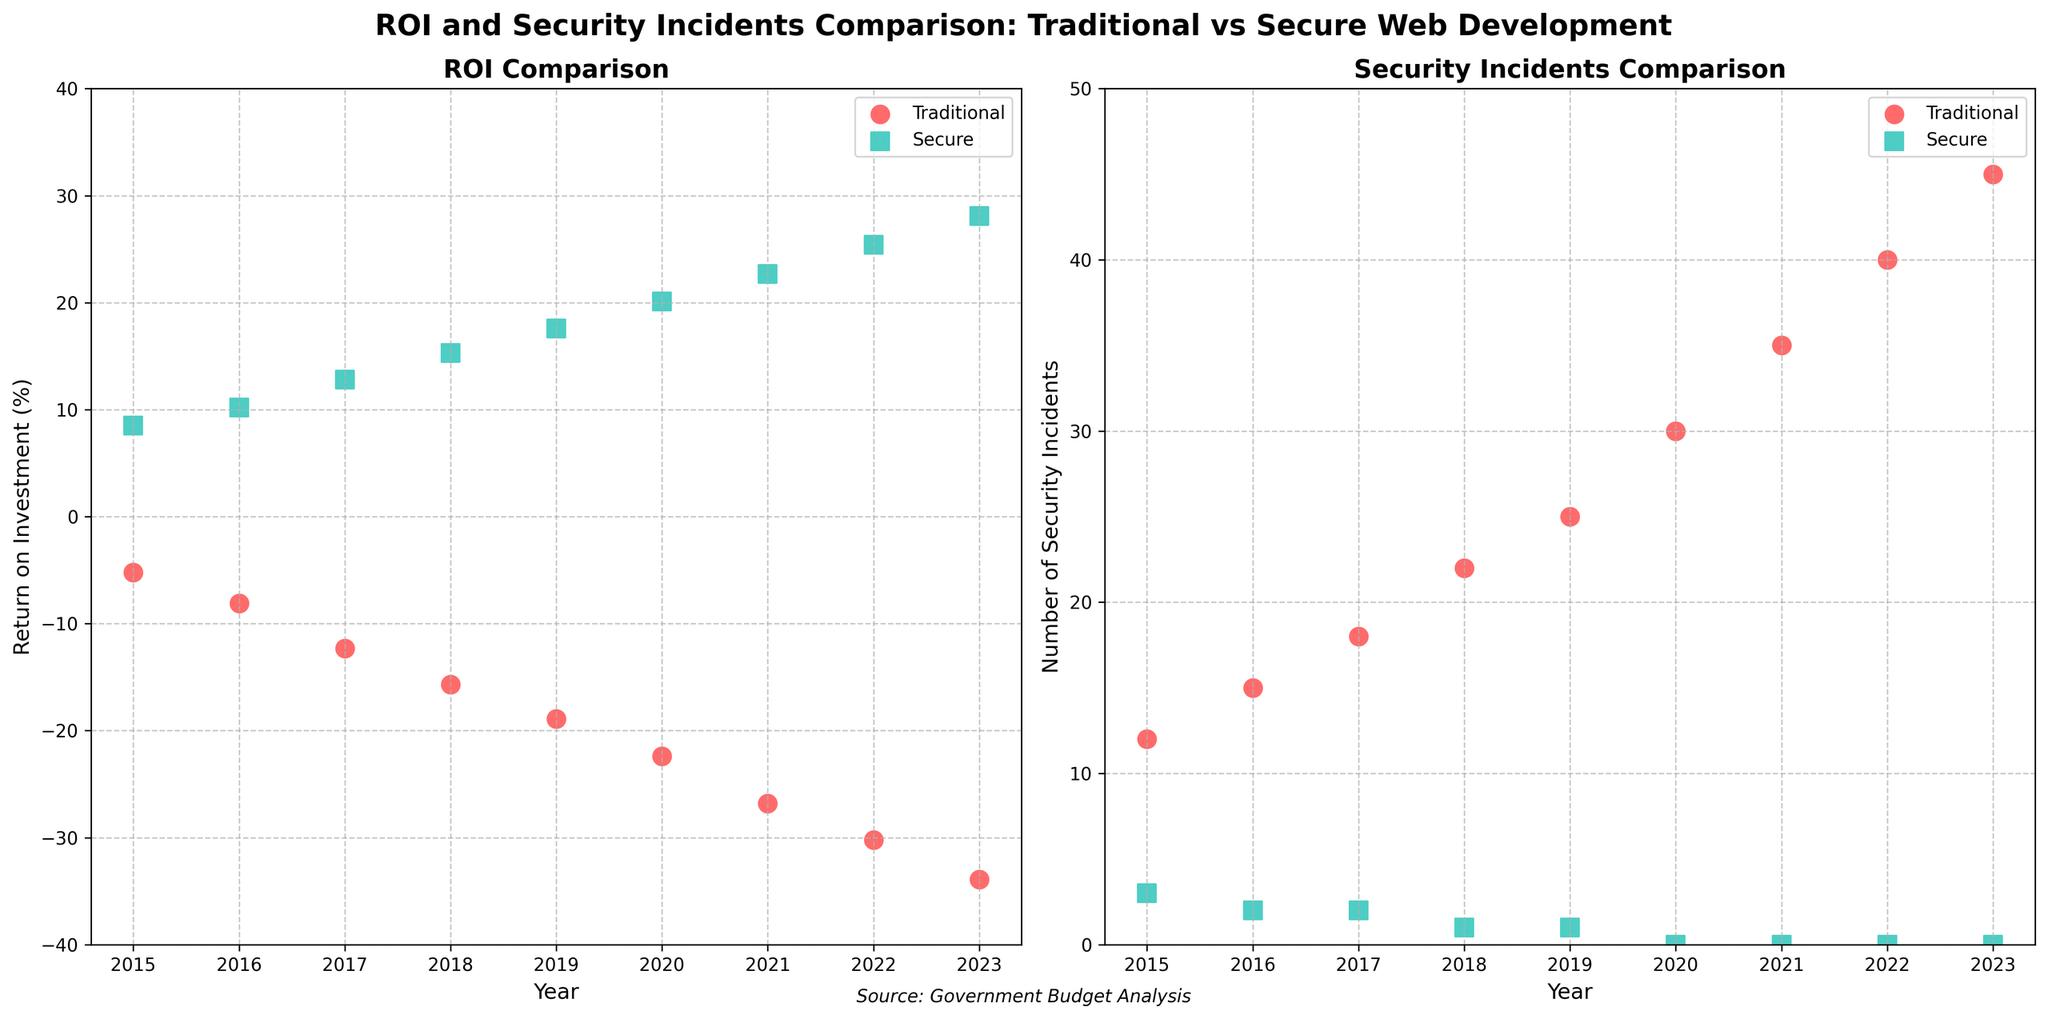What was the ROI for traditional development in 2019? From the 'ROI Comparison' scatter plot on the left, locate the data point for the year 2019 under the 'Traditional' label. The y-axis value for Traditional ROI in 2019 is around -18.9%.
Answer: -18.9% In which year did the secure web development have the maximum number of security incidents? From the 'Security Incidents Comparison' scatter plot on the right, check the data points under the 'Secure' label. The maximum number of security incidents for secure development is 3, which occurred in 2015.
Answer: 2015 Compare the ROI between traditional and secure methods in 2020. Which one had higher ROI and by how much? Locate the data points for 2020 on the 'ROI Comparison' scatter plot. The Traditional ROI is -22.4%, and the Secure ROI is 20.1%. The Secure method had a higher ROI by 20.1% - (-22.4%) = 42.5%.
Answer: Secure; 42.5% How did the number of traditional security incidents change from 2015 to 2023? From the 'Security Incidents Comparison' scatter plot, find the number of security incidents in 2015 (12 incidents) and in 2023 (45 incidents). The number increased by 45 - 12 = 33 incidents.
Answer: Increased by 33 In which year did the secure web development achieve the highest ROI? Examine the 'ROI Comparison' plot. The highest ROI for secure web development is 28.1%, which occurred in 2023.
Answer: 2023 What is the average number of security incidents per year for traditional methods between 2015 and 2023 inclusively? Sum up the security incidents for traditional methods from 2015 to 2023: 12 + 15 + 18 + 22 + 25 + 30 + 35 + 40 + 45 = 242. There are 9 years, so the average is 242 / 9 ≈ 26.89 incidents per year.
Answer: 26.89 Across all the years shown, what is the average ROI for the secure web development method? Add the ROI for secure methods for each year: 8.5 + 10.2 + 12.8 + 15.3 + 17.6 + 20.1 + 22.7 + 25.4 + 28.1 = 160.7. Divide by the number of years (9), so the average is 160.7 / 9 ≈ 17.9%.
Answer: 17.9% Between 2020 and 2023, how did the ROI for secure development change, and was this change positive or negative? From the 'ROI Comparison' plot, secure development ROI in 2020 was 20.1%, and in 2023 it was 28.1%. The change is 28.1% - 20.1% = 8%, which is a positive change.
Answer: Positive; 8% 